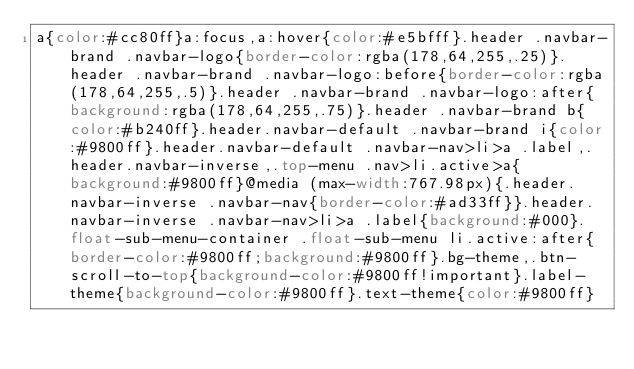Convert code to text. <code><loc_0><loc_0><loc_500><loc_500><_CSS_>a{color:#cc80ff}a:focus,a:hover{color:#e5bfff}.header .navbar-brand .navbar-logo{border-color:rgba(178,64,255,.25)}.header .navbar-brand .navbar-logo:before{border-color:rgba(178,64,255,.5)}.header .navbar-brand .navbar-logo:after{background:rgba(178,64,255,.75)}.header .navbar-brand b{color:#b240ff}.header.navbar-default .navbar-brand i{color:#9800ff}.header.navbar-default .navbar-nav>li>a .label,.header.navbar-inverse,.top-menu .nav>li.active>a{background:#9800ff}@media (max-width:767.98px){.header.navbar-inverse .navbar-nav{border-color:#ad33ff}}.header.navbar-inverse .navbar-nav>li>a .label{background:#000}.float-sub-menu-container .float-sub-menu li.active:after{border-color:#9800ff;background:#9800ff}.bg-theme,.btn-scroll-to-top{background-color:#9800ff!important}.label-theme{background-color:#9800ff}.text-theme{color:#9800ff}</code> 